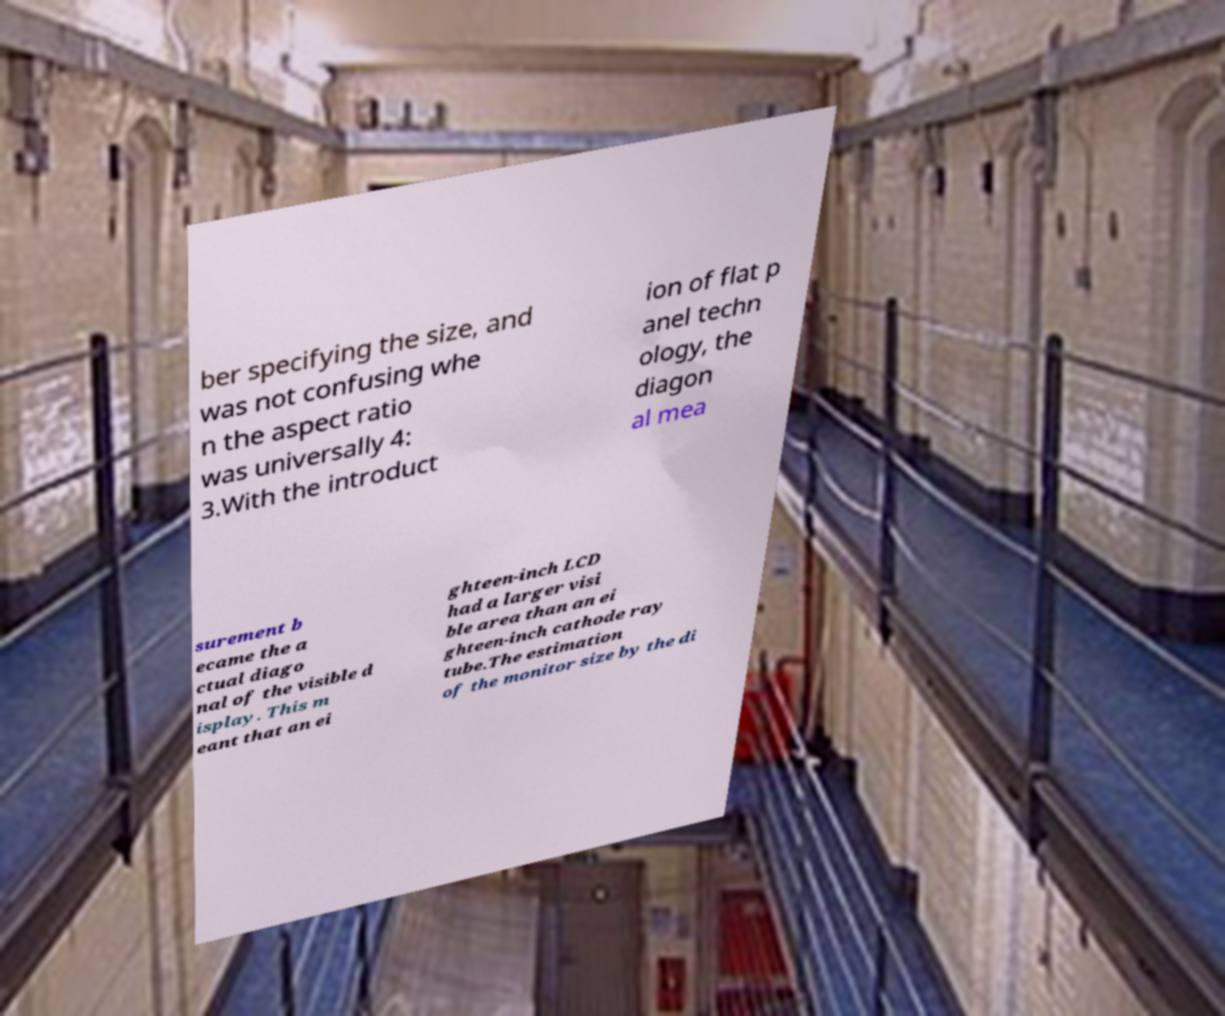For documentation purposes, I need the text within this image transcribed. Could you provide that? ber specifying the size, and was not confusing whe n the aspect ratio was universally 4: 3.With the introduct ion of flat p anel techn ology, the diagon al mea surement b ecame the a ctual diago nal of the visible d isplay. This m eant that an ei ghteen-inch LCD had a larger visi ble area than an ei ghteen-inch cathode ray tube.The estimation of the monitor size by the di 